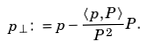Convert formula to latex. <formula><loc_0><loc_0><loc_500><loc_500>p _ { \perp } \colon = p - \frac { \langle p , P \rangle } { P ^ { 2 } } P .</formula> 